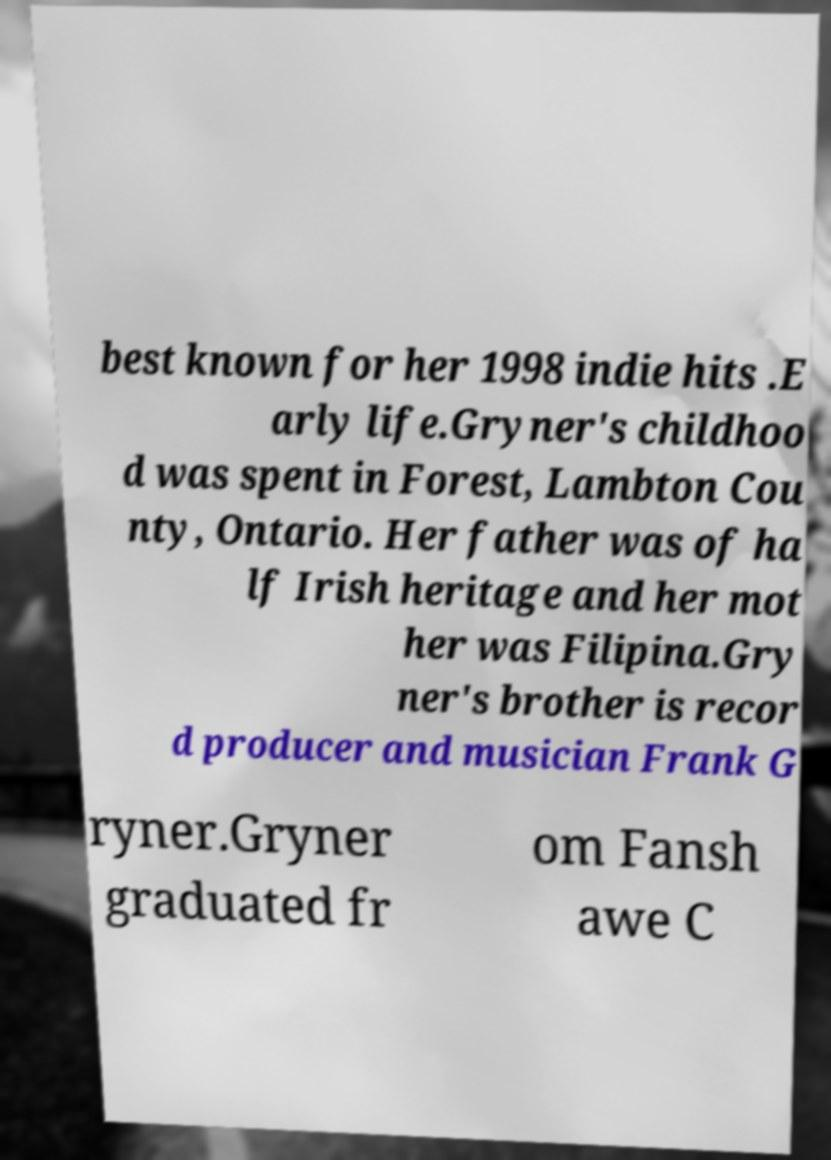Can you accurately transcribe the text from the provided image for me? best known for her 1998 indie hits .E arly life.Gryner's childhoo d was spent in Forest, Lambton Cou nty, Ontario. Her father was of ha lf Irish heritage and her mot her was Filipina.Gry ner's brother is recor d producer and musician Frank G ryner.Gryner graduated fr om Fansh awe C 